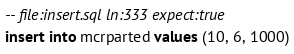<code> <loc_0><loc_0><loc_500><loc_500><_SQL_>-- file:insert.sql ln:333 expect:true
insert into mcrparted values (10, 6, 1000)
</code> 